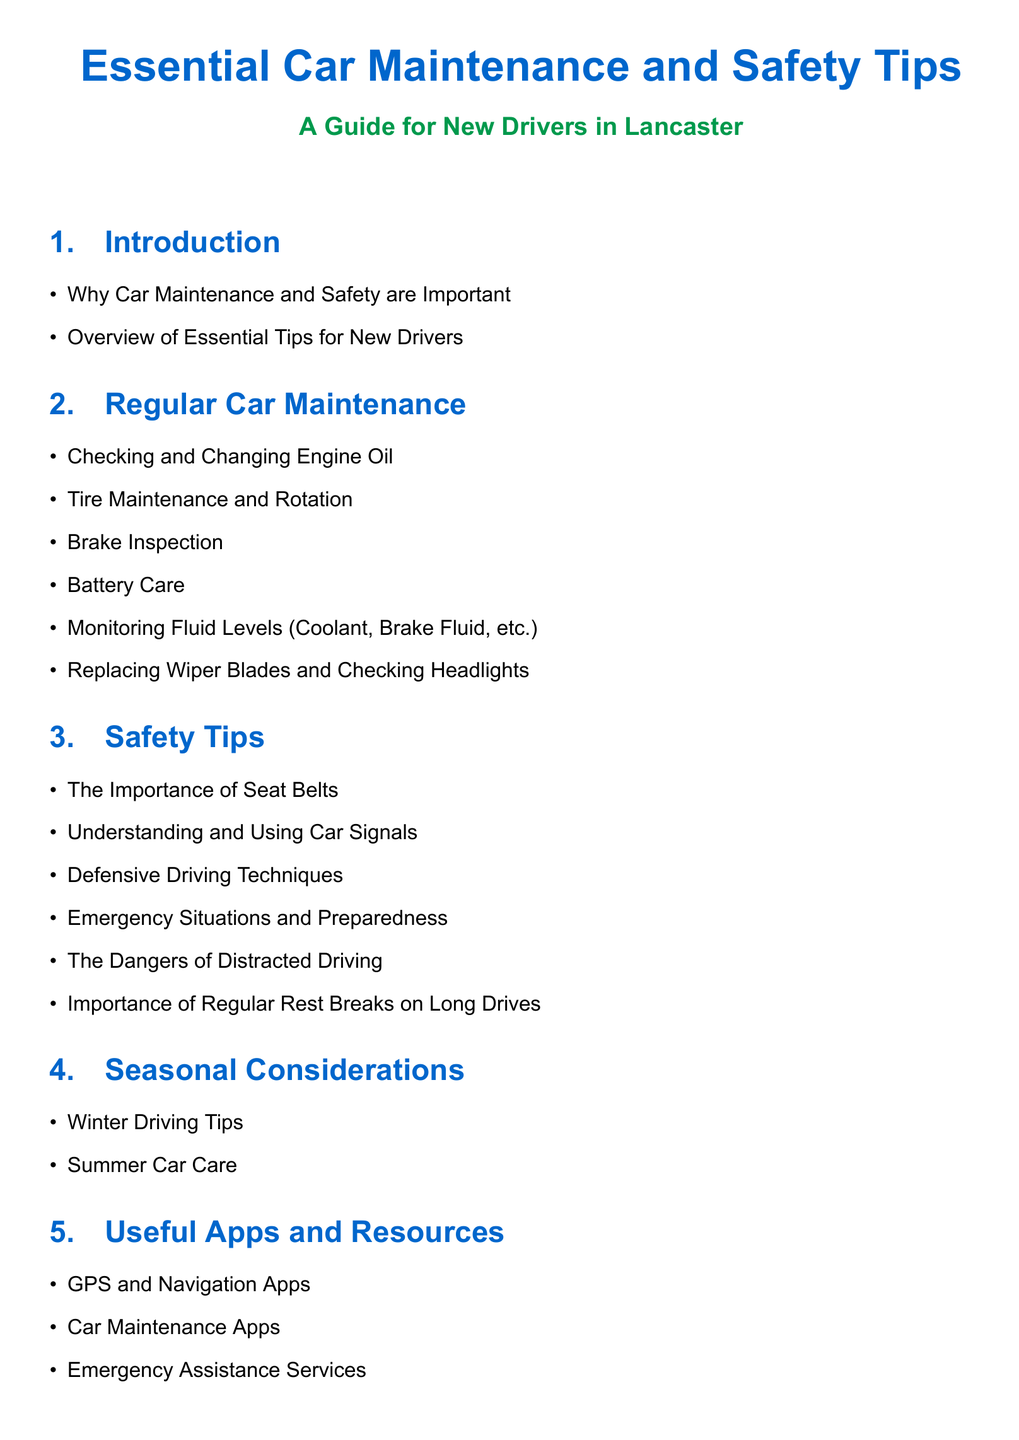What is the title of the document? The title of the document is presented prominently at the top.
Answer: Essential Car Maintenance and Safety Tips How many main sections are there in the document? The main sections of the document are listed after the title.
Answer: 5 What is the color used for section headings? The section headings are styled with a specific color as defined in the code.
Answer: myblue What is one of the tips listed under Regular Car Maintenance? The itemized list in this section includes several specific maintenance tasks.
Answer: Checking and Changing Engine Oil What is highlighted as a danger in the Safety Tips section? The document explicitly mentions certain behaviors in the Safety Tips section.
Answer: Distracted Driving Which section addresses driving conditions in different seasons? The title of this section indicates its focus on seasonal driving advice.
Answer: Seasonal Considerations Name one type of app mentioned in the Useful Apps and Resources section. This section provides examples of beneficial applications for drivers.
Answer: GPS and Navigation Apps What is the primary audience of this guide? The introduction specifies the target readers of the guide.
Answer: New Drivers in Lancaster What is a recommended action during emergency situations according to the Safety Tips? The document encourages a particular mindset for drivers in emergencies.
Answer: Preparedness 